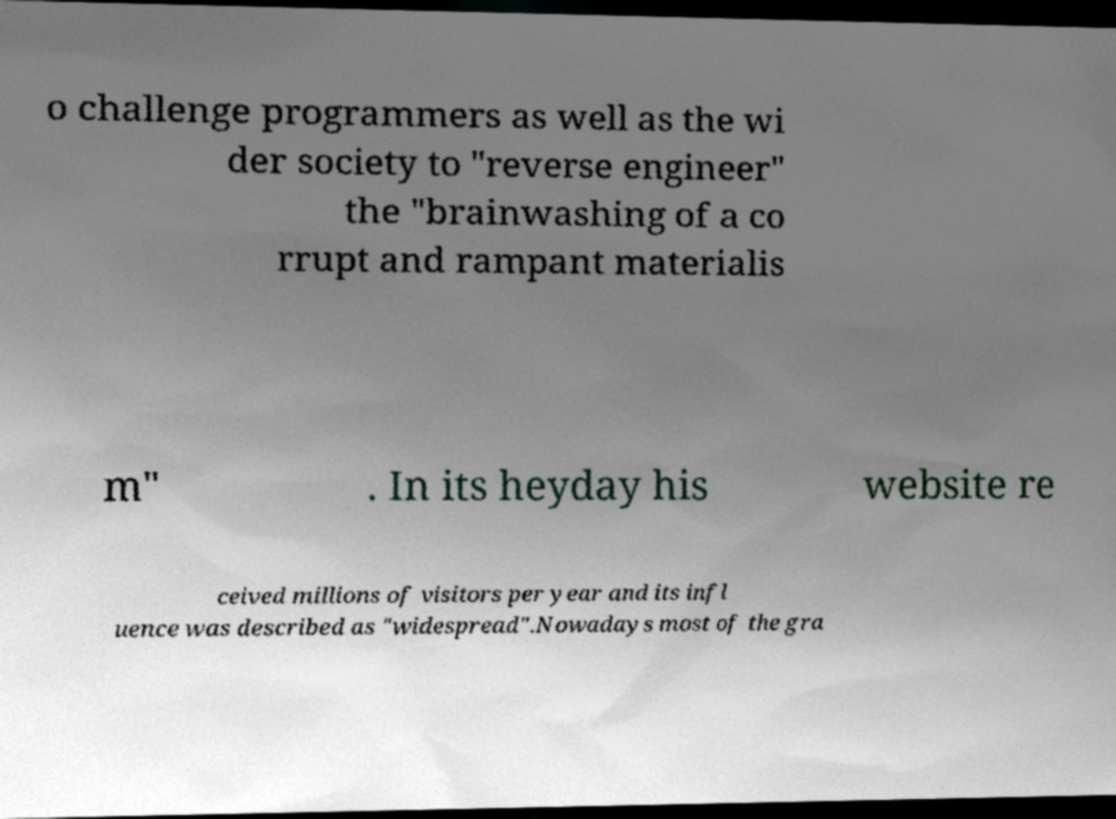Please identify and transcribe the text found in this image. o challenge programmers as well as the wi der society to "reverse engineer" the "brainwashing of a co rrupt and rampant materialis m" . In its heyday his website re ceived millions of visitors per year and its infl uence was described as "widespread".Nowadays most of the gra 